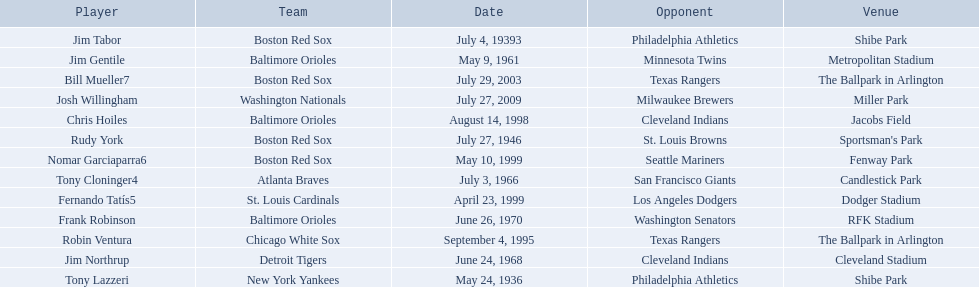Who were all the teams? New York Yankees, Boston Red Sox, Boston Red Sox, Baltimore Orioles, Atlanta Braves, Detroit Tigers, Baltimore Orioles, Chicago White Sox, Baltimore Orioles, St. Louis Cardinals, Boston Red Sox, Boston Red Sox, Washington Nationals. What about opponents? Philadelphia Athletics, Philadelphia Athletics, St. Louis Browns, Minnesota Twins, San Francisco Giants, Cleveland Indians, Washington Senators, Texas Rangers, Cleveland Indians, Los Angeles Dodgers, Seattle Mariners, Texas Rangers, Milwaukee Brewers. And when did they play? May 24, 1936, July 4, 19393, July 27, 1946, May 9, 1961, July 3, 1966, June 24, 1968, June 26, 1970, September 4, 1995, August 14, 1998, April 23, 1999, May 10, 1999, July 29, 2003, July 27, 2009. Which team played the red sox on july 27, 1946	? St. Louis Browns. 